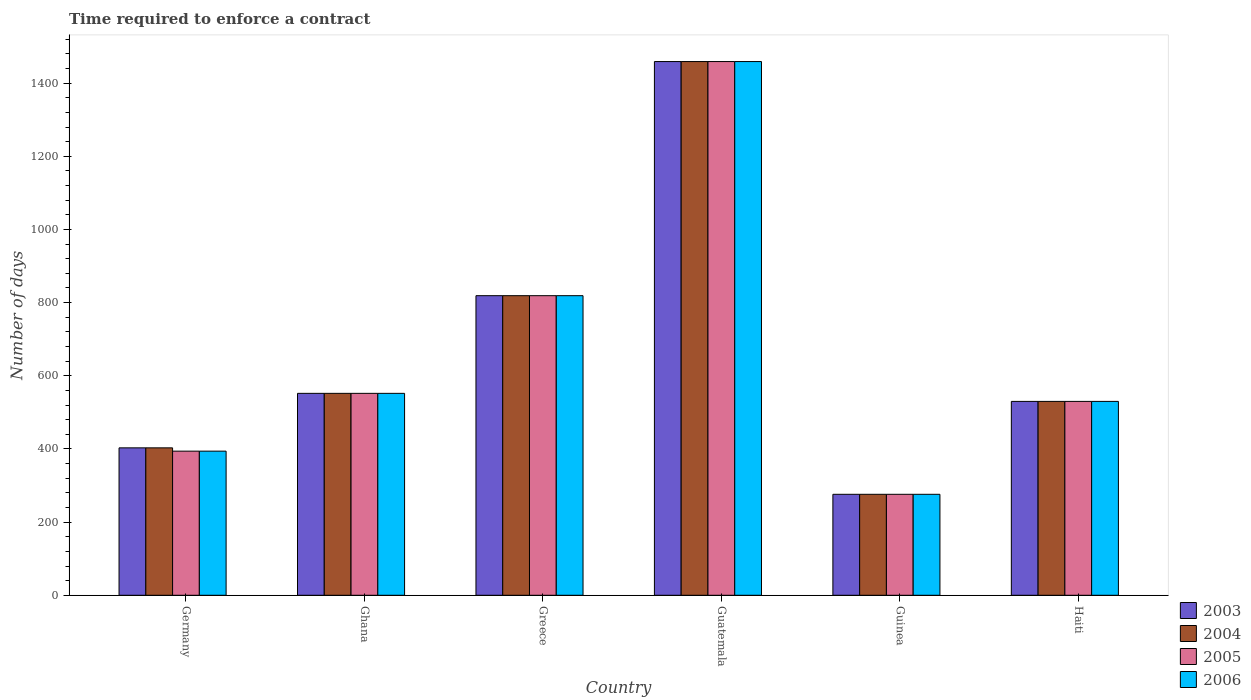Are the number of bars per tick equal to the number of legend labels?
Offer a terse response. Yes. Are the number of bars on each tick of the X-axis equal?
Provide a short and direct response. Yes. How many bars are there on the 1st tick from the right?
Ensure brevity in your answer.  4. What is the number of days required to enforce a contract in 2004 in Guinea?
Make the answer very short. 276. Across all countries, what is the maximum number of days required to enforce a contract in 2006?
Offer a very short reply. 1459. Across all countries, what is the minimum number of days required to enforce a contract in 2006?
Keep it short and to the point. 276. In which country was the number of days required to enforce a contract in 2006 maximum?
Provide a short and direct response. Guatemala. In which country was the number of days required to enforce a contract in 2004 minimum?
Your response must be concise. Guinea. What is the total number of days required to enforce a contract in 2006 in the graph?
Your response must be concise. 4030. What is the difference between the number of days required to enforce a contract in 2004 in Guinea and that in Haiti?
Your answer should be very brief. -254. What is the difference between the number of days required to enforce a contract in 2005 in Germany and the number of days required to enforce a contract in 2006 in Ghana?
Provide a succinct answer. -158. What is the average number of days required to enforce a contract in 2003 per country?
Offer a very short reply. 673.17. What is the difference between the number of days required to enforce a contract of/in 2003 and number of days required to enforce a contract of/in 2005 in Ghana?
Your response must be concise. 0. What is the ratio of the number of days required to enforce a contract in 2005 in Ghana to that in Guinea?
Make the answer very short. 2. Is the number of days required to enforce a contract in 2004 in Guatemala less than that in Guinea?
Provide a short and direct response. No. What is the difference between the highest and the second highest number of days required to enforce a contract in 2006?
Your answer should be very brief. -267. What is the difference between the highest and the lowest number of days required to enforce a contract in 2004?
Make the answer very short. 1183. In how many countries, is the number of days required to enforce a contract in 2004 greater than the average number of days required to enforce a contract in 2004 taken over all countries?
Offer a very short reply. 2. What does the 3rd bar from the right in Germany represents?
Your answer should be compact. 2004. How many bars are there?
Offer a terse response. 24. How many countries are there in the graph?
Give a very brief answer. 6. Are the values on the major ticks of Y-axis written in scientific E-notation?
Ensure brevity in your answer.  No. Does the graph contain any zero values?
Your answer should be compact. No. Where does the legend appear in the graph?
Your answer should be compact. Bottom right. What is the title of the graph?
Give a very brief answer. Time required to enforce a contract. What is the label or title of the Y-axis?
Your response must be concise. Number of days. What is the Number of days in 2003 in Germany?
Give a very brief answer. 403. What is the Number of days in 2004 in Germany?
Provide a succinct answer. 403. What is the Number of days in 2005 in Germany?
Ensure brevity in your answer.  394. What is the Number of days of 2006 in Germany?
Keep it short and to the point. 394. What is the Number of days in 2003 in Ghana?
Your answer should be compact. 552. What is the Number of days in 2004 in Ghana?
Make the answer very short. 552. What is the Number of days in 2005 in Ghana?
Your answer should be very brief. 552. What is the Number of days of 2006 in Ghana?
Give a very brief answer. 552. What is the Number of days of 2003 in Greece?
Your response must be concise. 819. What is the Number of days in 2004 in Greece?
Offer a terse response. 819. What is the Number of days of 2005 in Greece?
Offer a very short reply. 819. What is the Number of days of 2006 in Greece?
Provide a short and direct response. 819. What is the Number of days of 2003 in Guatemala?
Your response must be concise. 1459. What is the Number of days in 2004 in Guatemala?
Offer a terse response. 1459. What is the Number of days in 2005 in Guatemala?
Provide a succinct answer. 1459. What is the Number of days of 2006 in Guatemala?
Make the answer very short. 1459. What is the Number of days in 2003 in Guinea?
Offer a very short reply. 276. What is the Number of days in 2004 in Guinea?
Keep it short and to the point. 276. What is the Number of days in 2005 in Guinea?
Offer a very short reply. 276. What is the Number of days in 2006 in Guinea?
Give a very brief answer. 276. What is the Number of days of 2003 in Haiti?
Keep it short and to the point. 530. What is the Number of days in 2004 in Haiti?
Provide a succinct answer. 530. What is the Number of days in 2005 in Haiti?
Provide a short and direct response. 530. What is the Number of days in 2006 in Haiti?
Your response must be concise. 530. Across all countries, what is the maximum Number of days of 2003?
Offer a very short reply. 1459. Across all countries, what is the maximum Number of days in 2004?
Offer a terse response. 1459. Across all countries, what is the maximum Number of days of 2005?
Make the answer very short. 1459. Across all countries, what is the maximum Number of days in 2006?
Make the answer very short. 1459. Across all countries, what is the minimum Number of days in 2003?
Keep it short and to the point. 276. Across all countries, what is the minimum Number of days of 2004?
Your response must be concise. 276. Across all countries, what is the minimum Number of days of 2005?
Keep it short and to the point. 276. Across all countries, what is the minimum Number of days in 2006?
Your answer should be very brief. 276. What is the total Number of days of 2003 in the graph?
Make the answer very short. 4039. What is the total Number of days of 2004 in the graph?
Provide a short and direct response. 4039. What is the total Number of days of 2005 in the graph?
Give a very brief answer. 4030. What is the total Number of days in 2006 in the graph?
Offer a very short reply. 4030. What is the difference between the Number of days in 2003 in Germany and that in Ghana?
Offer a very short reply. -149. What is the difference between the Number of days in 2004 in Germany and that in Ghana?
Offer a very short reply. -149. What is the difference between the Number of days in 2005 in Germany and that in Ghana?
Provide a short and direct response. -158. What is the difference between the Number of days in 2006 in Germany and that in Ghana?
Your answer should be very brief. -158. What is the difference between the Number of days of 2003 in Germany and that in Greece?
Provide a short and direct response. -416. What is the difference between the Number of days of 2004 in Germany and that in Greece?
Your answer should be compact. -416. What is the difference between the Number of days of 2005 in Germany and that in Greece?
Your answer should be very brief. -425. What is the difference between the Number of days in 2006 in Germany and that in Greece?
Ensure brevity in your answer.  -425. What is the difference between the Number of days in 2003 in Germany and that in Guatemala?
Ensure brevity in your answer.  -1056. What is the difference between the Number of days of 2004 in Germany and that in Guatemala?
Your answer should be very brief. -1056. What is the difference between the Number of days of 2005 in Germany and that in Guatemala?
Your answer should be compact. -1065. What is the difference between the Number of days in 2006 in Germany and that in Guatemala?
Offer a very short reply. -1065. What is the difference between the Number of days in 2003 in Germany and that in Guinea?
Your response must be concise. 127. What is the difference between the Number of days in 2004 in Germany and that in Guinea?
Offer a very short reply. 127. What is the difference between the Number of days of 2005 in Germany and that in Guinea?
Keep it short and to the point. 118. What is the difference between the Number of days in 2006 in Germany and that in Guinea?
Keep it short and to the point. 118. What is the difference between the Number of days in 2003 in Germany and that in Haiti?
Your answer should be very brief. -127. What is the difference between the Number of days in 2004 in Germany and that in Haiti?
Keep it short and to the point. -127. What is the difference between the Number of days in 2005 in Germany and that in Haiti?
Your answer should be very brief. -136. What is the difference between the Number of days in 2006 in Germany and that in Haiti?
Offer a very short reply. -136. What is the difference between the Number of days in 2003 in Ghana and that in Greece?
Make the answer very short. -267. What is the difference between the Number of days of 2004 in Ghana and that in Greece?
Your answer should be very brief. -267. What is the difference between the Number of days of 2005 in Ghana and that in Greece?
Your answer should be compact. -267. What is the difference between the Number of days in 2006 in Ghana and that in Greece?
Provide a short and direct response. -267. What is the difference between the Number of days of 2003 in Ghana and that in Guatemala?
Keep it short and to the point. -907. What is the difference between the Number of days of 2004 in Ghana and that in Guatemala?
Your answer should be compact. -907. What is the difference between the Number of days of 2005 in Ghana and that in Guatemala?
Make the answer very short. -907. What is the difference between the Number of days of 2006 in Ghana and that in Guatemala?
Ensure brevity in your answer.  -907. What is the difference between the Number of days of 2003 in Ghana and that in Guinea?
Give a very brief answer. 276. What is the difference between the Number of days in 2004 in Ghana and that in Guinea?
Make the answer very short. 276. What is the difference between the Number of days in 2005 in Ghana and that in Guinea?
Provide a succinct answer. 276. What is the difference between the Number of days of 2006 in Ghana and that in Guinea?
Ensure brevity in your answer.  276. What is the difference between the Number of days in 2004 in Ghana and that in Haiti?
Offer a very short reply. 22. What is the difference between the Number of days in 2005 in Ghana and that in Haiti?
Provide a succinct answer. 22. What is the difference between the Number of days of 2006 in Ghana and that in Haiti?
Provide a succinct answer. 22. What is the difference between the Number of days of 2003 in Greece and that in Guatemala?
Ensure brevity in your answer.  -640. What is the difference between the Number of days in 2004 in Greece and that in Guatemala?
Your answer should be very brief. -640. What is the difference between the Number of days in 2005 in Greece and that in Guatemala?
Your response must be concise. -640. What is the difference between the Number of days of 2006 in Greece and that in Guatemala?
Offer a terse response. -640. What is the difference between the Number of days in 2003 in Greece and that in Guinea?
Offer a terse response. 543. What is the difference between the Number of days in 2004 in Greece and that in Guinea?
Your response must be concise. 543. What is the difference between the Number of days in 2005 in Greece and that in Guinea?
Your response must be concise. 543. What is the difference between the Number of days of 2006 in Greece and that in Guinea?
Provide a succinct answer. 543. What is the difference between the Number of days in 2003 in Greece and that in Haiti?
Ensure brevity in your answer.  289. What is the difference between the Number of days of 2004 in Greece and that in Haiti?
Offer a terse response. 289. What is the difference between the Number of days in 2005 in Greece and that in Haiti?
Keep it short and to the point. 289. What is the difference between the Number of days of 2006 in Greece and that in Haiti?
Ensure brevity in your answer.  289. What is the difference between the Number of days of 2003 in Guatemala and that in Guinea?
Make the answer very short. 1183. What is the difference between the Number of days of 2004 in Guatemala and that in Guinea?
Give a very brief answer. 1183. What is the difference between the Number of days in 2005 in Guatemala and that in Guinea?
Offer a very short reply. 1183. What is the difference between the Number of days in 2006 in Guatemala and that in Guinea?
Keep it short and to the point. 1183. What is the difference between the Number of days in 2003 in Guatemala and that in Haiti?
Your response must be concise. 929. What is the difference between the Number of days in 2004 in Guatemala and that in Haiti?
Your answer should be very brief. 929. What is the difference between the Number of days of 2005 in Guatemala and that in Haiti?
Ensure brevity in your answer.  929. What is the difference between the Number of days of 2006 in Guatemala and that in Haiti?
Your answer should be very brief. 929. What is the difference between the Number of days of 2003 in Guinea and that in Haiti?
Give a very brief answer. -254. What is the difference between the Number of days of 2004 in Guinea and that in Haiti?
Provide a succinct answer. -254. What is the difference between the Number of days in 2005 in Guinea and that in Haiti?
Your answer should be very brief. -254. What is the difference between the Number of days of 2006 in Guinea and that in Haiti?
Provide a short and direct response. -254. What is the difference between the Number of days in 2003 in Germany and the Number of days in 2004 in Ghana?
Your response must be concise. -149. What is the difference between the Number of days of 2003 in Germany and the Number of days of 2005 in Ghana?
Offer a very short reply. -149. What is the difference between the Number of days in 2003 in Germany and the Number of days in 2006 in Ghana?
Provide a short and direct response. -149. What is the difference between the Number of days of 2004 in Germany and the Number of days of 2005 in Ghana?
Your answer should be very brief. -149. What is the difference between the Number of days of 2004 in Germany and the Number of days of 2006 in Ghana?
Provide a short and direct response. -149. What is the difference between the Number of days of 2005 in Germany and the Number of days of 2006 in Ghana?
Provide a succinct answer. -158. What is the difference between the Number of days of 2003 in Germany and the Number of days of 2004 in Greece?
Offer a very short reply. -416. What is the difference between the Number of days of 2003 in Germany and the Number of days of 2005 in Greece?
Your answer should be compact. -416. What is the difference between the Number of days in 2003 in Germany and the Number of days in 2006 in Greece?
Your response must be concise. -416. What is the difference between the Number of days of 2004 in Germany and the Number of days of 2005 in Greece?
Make the answer very short. -416. What is the difference between the Number of days of 2004 in Germany and the Number of days of 2006 in Greece?
Keep it short and to the point. -416. What is the difference between the Number of days in 2005 in Germany and the Number of days in 2006 in Greece?
Provide a succinct answer. -425. What is the difference between the Number of days in 2003 in Germany and the Number of days in 2004 in Guatemala?
Offer a very short reply. -1056. What is the difference between the Number of days of 2003 in Germany and the Number of days of 2005 in Guatemala?
Keep it short and to the point. -1056. What is the difference between the Number of days in 2003 in Germany and the Number of days in 2006 in Guatemala?
Provide a succinct answer. -1056. What is the difference between the Number of days of 2004 in Germany and the Number of days of 2005 in Guatemala?
Make the answer very short. -1056. What is the difference between the Number of days of 2004 in Germany and the Number of days of 2006 in Guatemala?
Ensure brevity in your answer.  -1056. What is the difference between the Number of days in 2005 in Germany and the Number of days in 2006 in Guatemala?
Provide a succinct answer. -1065. What is the difference between the Number of days in 2003 in Germany and the Number of days in 2004 in Guinea?
Make the answer very short. 127. What is the difference between the Number of days in 2003 in Germany and the Number of days in 2005 in Guinea?
Your answer should be compact. 127. What is the difference between the Number of days of 2003 in Germany and the Number of days of 2006 in Guinea?
Provide a succinct answer. 127. What is the difference between the Number of days of 2004 in Germany and the Number of days of 2005 in Guinea?
Provide a succinct answer. 127. What is the difference between the Number of days in 2004 in Germany and the Number of days in 2006 in Guinea?
Offer a terse response. 127. What is the difference between the Number of days in 2005 in Germany and the Number of days in 2006 in Guinea?
Your answer should be compact. 118. What is the difference between the Number of days in 2003 in Germany and the Number of days in 2004 in Haiti?
Provide a short and direct response. -127. What is the difference between the Number of days of 2003 in Germany and the Number of days of 2005 in Haiti?
Your response must be concise. -127. What is the difference between the Number of days in 2003 in Germany and the Number of days in 2006 in Haiti?
Your answer should be very brief. -127. What is the difference between the Number of days of 2004 in Germany and the Number of days of 2005 in Haiti?
Your answer should be compact. -127. What is the difference between the Number of days in 2004 in Germany and the Number of days in 2006 in Haiti?
Ensure brevity in your answer.  -127. What is the difference between the Number of days of 2005 in Germany and the Number of days of 2006 in Haiti?
Your answer should be compact. -136. What is the difference between the Number of days in 2003 in Ghana and the Number of days in 2004 in Greece?
Offer a very short reply. -267. What is the difference between the Number of days of 2003 in Ghana and the Number of days of 2005 in Greece?
Ensure brevity in your answer.  -267. What is the difference between the Number of days in 2003 in Ghana and the Number of days in 2006 in Greece?
Offer a terse response. -267. What is the difference between the Number of days of 2004 in Ghana and the Number of days of 2005 in Greece?
Provide a succinct answer. -267. What is the difference between the Number of days in 2004 in Ghana and the Number of days in 2006 in Greece?
Ensure brevity in your answer.  -267. What is the difference between the Number of days in 2005 in Ghana and the Number of days in 2006 in Greece?
Your answer should be very brief. -267. What is the difference between the Number of days of 2003 in Ghana and the Number of days of 2004 in Guatemala?
Offer a terse response. -907. What is the difference between the Number of days of 2003 in Ghana and the Number of days of 2005 in Guatemala?
Ensure brevity in your answer.  -907. What is the difference between the Number of days of 2003 in Ghana and the Number of days of 2006 in Guatemala?
Offer a very short reply. -907. What is the difference between the Number of days in 2004 in Ghana and the Number of days in 2005 in Guatemala?
Your answer should be very brief. -907. What is the difference between the Number of days of 2004 in Ghana and the Number of days of 2006 in Guatemala?
Make the answer very short. -907. What is the difference between the Number of days of 2005 in Ghana and the Number of days of 2006 in Guatemala?
Keep it short and to the point. -907. What is the difference between the Number of days in 2003 in Ghana and the Number of days in 2004 in Guinea?
Make the answer very short. 276. What is the difference between the Number of days in 2003 in Ghana and the Number of days in 2005 in Guinea?
Provide a succinct answer. 276. What is the difference between the Number of days in 2003 in Ghana and the Number of days in 2006 in Guinea?
Offer a very short reply. 276. What is the difference between the Number of days of 2004 in Ghana and the Number of days of 2005 in Guinea?
Keep it short and to the point. 276. What is the difference between the Number of days in 2004 in Ghana and the Number of days in 2006 in Guinea?
Give a very brief answer. 276. What is the difference between the Number of days of 2005 in Ghana and the Number of days of 2006 in Guinea?
Ensure brevity in your answer.  276. What is the difference between the Number of days in 2003 in Ghana and the Number of days in 2004 in Haiti?
Offer a terse response. 22. What is the difference between the Number of days in 2004 in Ghana and the Number of days in 2006 in Haiti?
Ensure brevity in your answer.  22. What is the difference between the Number of days of 2003 in Greece and the Number of days of 2004 in Guatemala?
Give a very brief answer. -640. What is the difference between the Number of days of 2003 in Greece and the Number of days of 2005 in Guatemala?
Offer a terse response. -640. What is the difference between the Number of days in 2003 in Greece and the Number of days in 2006 in Guatemala?
Your answer should be compact. -640. What is the difference between the Number of days in 2004 in Greece and the Number of days in 2005 in Guatemala?
Keep it short and to the point. -640. What is the difference between the Number of days of 2004 in Greece and the Number of days of 2006 in Guatemala?
Your response must be concise. -640. What is the difference between the Number of days in 2005 in Greece and the Number of days in 2006 in Guatemala?
Keep it short and to the point. -640. What is the difference between the Number of days in 2003 in Greece and the Number of days in 2004 in Guinea?
Provide a succinct answer. 543. What is the difference between the Number of days in 2003 in Greece and the Number of days in 2005 in Guinea?
Your answer should be very brief. 543. What is the difference between the Number of days in 2003 in Greece and the Number of days in 2006 in Guinea?
Offer a very short reply. 543. What is the difference between the Number of days in 2004 in Greece and the Number of days in 2005 in Guinea?
Your answer should be very brief. 543. What is the difference between the Number of days in 2004 in Greece and the Number of days in 2006 in Guinea?
Give a very brief answer. 543. What is the difference between the Number of days in 2005 in Greece and the Number of days in 2006 in Guinea?
Provide a succinct answer. 543. What is the difference between the Number of days in 2003 in Greece and the Number of days in 2004 in Haiti?
Your answer should be very brief. 289. What is the difference between the Number of days in 2003 in Greece and the Number of days in 2005 in Haiti?
Provide a short and direct response. 289. What is the difference between the Number of days of 2003 in Greece and the Number of days of 2006 in Haiti?
Your response must be concise. 289. What is the difference between the Number of days in 2004 in Greece and the Number of days in 2005 in Haiti?
Ensure brevity in your answer.  289. What is the difference between the Number of days of 2004 in Greece and the Number of days of 2006 in Haiti?
Make the answer very short. 289. What is the difference between the Number of days in 2005 in Greece and the Number of days in 2006 in Haiti?
Ensure brevity in your answer.  289. What is the difference between the Number of days of 2003 in Guatemala and the Number of days of 2004 in Guinea?
Offer a terse response. 1183. What is the difference between the Number of days in 2003 in Guatemala and the Number of days in 2005 in Guinea?
Provide a short and direct response. 1183. What is the difference between the Number of days in 2003 in Guatemala and the Number of days in 2006 in Guinea?
Make the answer very short. 1183. What is the difference between the Number of days of 2004 in Guatemala and the Number of days of 2005 in Guinea?
Keep it short and to the point. 1183. What is the difference between the Number of days in 2004 in Guatemala and the Number of days in 2006 in Guinea?
Your answer should be compact. 1183. What is the difference between the Number of days in 2005 in Guatemala and the Number of days in 2006 in Guinea?
Ensure brevity in your answer.  1183. What is the difference between the Number of days in 2003 in Guatemala and the Number of days in 2004 in Haiti?
Offer a terse response. 929. What is the difference between the Number of days in 2003 in Guatemala and the Number of days in 2005 in Haiti?
Ensure brevity in your answer.  929. What is the difference between the Number of days of 2003 in Guatemala and the Number of days of 2006 in Haiti?
Your answer should be compact. 929. What is the difference between the Number of days of 2004 in Guatemala and the Number of days of 2005 in Haiti?
Offer a terse response. 929. What is the difference between the Number of days of 2004 in Guatemala and the Number of days of 2006 in Haiti?
Your response must be concise. 929. What is the difference between the Number of days in 2005 in Guatemala and the Number of days in 2006 in Haiti?
Your answer should be very brief. 929. What is the difference between the Number of days of 2003 in Guinea and the Number of days of 2004 in Haiti?
Make the answer very short. -254. What is the difference between the Number of days of 2003 in Guinea and the Number of days of 2005 in Haiti?
Ensure brevity in your answer.  -254. What is the difference between the Number of days of 2003 in Guinea and the Number of days of 2006 in Haiti?
Give a very brief answer. -254. What is the difference between the Number of days of 2004 in Guinea and the Number of days of 2005 in Haiti?
Give a very brief answer. -254. What is the difference between the Number of days in 2004 in Guinea and the Number of days in 2006 in Haiti?
Ensure brevity in your answer.  -254. What is the difference between the Number of days in 2005 in Guinea and the Number of days in 2006 in Haiti?
Give a very brief answer. -254. What is the average Number of days of 2003 per country?
Provide a succinct answer. 673.17. What is the average Number of days of 2004 per country?
Give a very brief answer. 673.17. What is the average Number of days in 2005 per country?
Provide a short and direct response. 671.67. What is the average Number of days in 2006 per country?
Your response must be concise. 671.67. What is the difference between the Number of days of 2003 and Number of days of 2004 in Germany?
Your answer should be compact. 0. What is the difference between the Number of days in 2004 and Number of days in 2006 in Germany?
Your response must be concise. 9. What is the difference between the Number of days in 2003 and Number of days in 2005 in Ghana?
Offer a very short reply. 0. What is the difference between the Number of days of 2003 and Number of days of 2006 in Ghana?
Provide a short and direct response. 0. What is the difference between the Number of days of 2004 and Number of days of 2005 in Ghana?
Your response must be concise. 0. What is the difference between the Number of days of 2004 and Number of days of 2006 in Ghana?
Offer a terse response. 0. What is the difference between the Number of days of 2003 and Number of days of 2004 in Greece?
Make the answer very short. 0. What is the difference between the Number of days in 2003 and Number of days in 2005 in Greece?
Your response must be concise. 0. What is the difference between the Number of days of 2003 and Number of days of 2006 in Greece?
Provide a succinct answer. 0. What is the difference between the Number of days in 2004 and Number of days in 2005 in Greece?
Offer a terse response. 0. What is the difference between the Number of days of 2004 and Number of days of 2006 in Greece?
Give a very brief answer. 0. What is the difference between the Number of days of 2005 and Number of days of 2006 in Greece?
Keep it short and to the point. 0. What is the difference between the Number of days of 2003 and Number of days of 2004 in Guatemala?
Ensure brevity in your answer.  0. What is the difference between the Number of days in 2003 and Number of days in 2006 in Guatemala?
Offer a very short reply. 0. What is the difference between the Number of days of 2004 and Number of days of 2005 in Guatemala?
Make the answer very short. 0. What is the difference between the Number of days of 2005 and Number of days of 2006 in Guatemala?
Provide a succinct answer. 0. What is the difference between the Number of days in 2003 and Number of days in 2005 in Guinea?
Provide a succinct answer. 0. What is the difference between the Number of days of 2004 and Number of days of 2006 in Guinea?
Provide a short and direct response. 0. What is the difference between the Number of days in 2005 and Number of days in 2006 in Guinea?
Provide a short and direct response. 0. What is the difference between the Number of days of 2003 and Number of days of 2006 in Haiti?
Provide a succinct answer. 0. What is the difference between the Number of days in 2005 and Number of days in 2006 in Haiti?
Your response must be concise. 0. What is the ratio of the Number of days of 2003 in Germany to that in Ghana?
Provide a succinct answer. 0.73. What is the ratio of the Number of days of 2004 in Germany to that in Ghana?
Keep it short and to the point. 0.73. What is the ratio of the Number of days of 2005 in Germany to that in Ghana?
Ensure brevity in your answer.  0.71. What is the ratio of the Number of days of 2006 in Germany to that in Ghana?
Provide a short and direct response. 0.71. What is the ratio of the Number of days in 2003 in Germany to that in Greece?
Provide a succinct answer. 0.49. What is the ratio of the Number of days of 2004 in Germany to that in Greece?
Offer a very short reply. 0.49. What is the ratio of the Number of days in 2005 in Germany to that in Greece?
Give a very brief answer. 0.48. What is the ratio of the Number of days of 2006 in Germany to that in Greece?
Make the answer very short. 0.48. What is the ratio of the Number of days in 2003 in Germany to that in Guatemala?
Offer a terse response. 0.28. What is the ratio of the Number of days in 2004 in Germany to that in Guatemala?
Offer a very short reply. 0.28. What is the ratio of the Number of days of 2005 in Germany to that in Guatemala?
Your answer should be very brief. 0.27. What is the ratio of the Number of days of 2006 in Germany to that in Guatemala?
Offer a very short reply. 0.27. What is the ratio of the Number of days of 2003 in Germany to that in Guinea?
Your response must be concise. 1.46. What is the ratio of the Number of days in 2004 in Germany to that in Guinea?
Provide a short and direct response. 1.46. What is the ratio of the Number of days in 2005 in Germany to that in Guinea?
Your answer should be very brief. 1.43. What is the ratio of the Number of days of 2006 in Germany to that in Guinea?
Give a very brief answer. 1.43. What is the ratio of the Number of days in 2003 in Germany to that in Haiti?
Give a very brief answer. 0.76. What is the ratio of the Number of days of 2004 in Germany to that in Haiti?
Your answer should be very brief. 0.76. What is the ratio of the Number of days in 2005 in Germany to that in Haiti?
Give a very brief answer. 0.74. What is the ratio of the Number of days in 2006 in Germany to that in Haiti?
Provide a short and direct response. 0.74. What is the ratio of the Number of days in 2003 in Ghana to that in Greece?
Make the answer very short. 0.67. What is the ratio of the Number of days of 2004 in Ghana to that in Greece?
Make the answer very short. 0.67. What is the ratio of the Number of days in 2005 in Ghana to that in Greece?
Your response must be concise. 0.67. What is the ratio of the Number of days in 2006 in Ghana to that in Greece?
Provide a short and direct response. 0.67. What is the ratio of the Number of days of 2003 in Ghana to that in Guatemala?
Offer a very short reply. 0.38. What is the ratio of the Number of days of 2004 in Ghana to that in Guatemala?
Make the answer very short. 0.38. What is the ratio of the Number of days of 2005 in Ghana to that in Guatemala?
Provide a short and direct response. 0.38. What is the ratio of the Number of days of 2006 in Ghana to that in Guatemala?
Offer a terse response. 0.38. What is the ratio of the Number of days in 2003 in Ghana to that in Guinea?
Offer a very short reply. 2. What is the ratio of the Number of days of 2004 in Ghana to that in Guinea?
Provide a succinct answer. 2. What is the ratio of the Number of days of 2005 in Ghana to that in Guinea?
Offer a very short reply. 2. What is the ratio of the Number of days of 2003 in Ghana to that in Haiti?
Your answer should be very brief. 1.04. What is the ratio of the Number of days of 2004 in Ghana to that in Haiti?
Make the answer very short. 1.04. What is the ratio of the Number of days in 2005 in Ghana to that in Haiti?
Your answer should be very brief. 1.04. What is the ratio of the Number of days in 2006 in Ghana to that in Haiti?
Offer a terse response. 1.04. What is the ratio of the Number of days in 2003 in Greece to that in Guatemala?
Make the answer very short. 0.56. What is the ratio of the Number of days of 2004 in Greece to that in Guatemala?
Provide a short and direct response. 0.56. What is the ratio of the Number of days of 2005 in Greece to that in Guatemala?
Offer a very short reply. 0.56. What is the ratio of the Number of days of 2006 in Greece to that in Guatemala?
Make the answer very short. 0.56. What is the ratio of the Number of days of 2003 in Greece to that in Guinea?
Ensure brevity in your answer.  2.97. What is the ratio of the Number of days of 2004 in Greece to that in Guinea?
Your response must be concise. 2.97. What is the ratio of the Number of days of 2005 in Greece to that in Guinea?
Offer a terse response. 2.97. What is the ratio of the Number of days of 2006 in Greece to that in Guinea?
Keep it short and to the point. 2.97. What is the ratio of the Number of days in 2003 in Greece to that in Haiti?
Give a very brief answer. 1.55. What is the ratio of the Number of days in 2004 in Greece to that in Haiti?
Make the answer very short. 1.55. What is the ratio of the Number of days of 2005 in Greece to that in Haiti?
Provide a short and direct response. 1.55. What is the ratio of the Number of days in 2006 in Greece to that in Haiti?
Give a very brief answer. 1.55. What is the ratio of the Number of days in 2003 in Guatemala to that in Guinea?
Provide a short and direct response. 5.29. What is the ratio of the Number of days in 2004 in Guatemala to that in Guinea?
Keep it short and to the point. 5.29. What is the ratio of the Number of days of 2005 in Guatemala to that in Guinea?
Ensure brevity in your answer.  5.29. What is the ratio of the Number of days of 2006 in Guatemala to that in Guinea?
Give a very brief answer. 5.29. What is the ratio of the Number of days of 2003 in Guatemala to that in Haiti?
Provide a short and direct response. 2.75. What is the ratio of the Number of days of 2004 in Guatemala to that in Haiti?
Keep it short and to the point. 2.75. What is the ratio of the Number of days in 2005 in Guatemala to that in Haiti?
Your answer should be compact. 2.75. What is the ratio of the Number of days of 2006 in Guatemala to that in Haiti?
Give a very brief answer. 2.75. What is the ratio of the Number of days in 2003 in Guinea to that in Haiti?
Provide a succinct answer. 0.52. What is the ratio of the Number of days in 2004 in Guinea to that in Haiti?
Ensure brevity in your answer.  0.52. What is the ratio of the Number of days of 2005 in Guinea to that in Haiti?
Offer a terse response. 0.52. What is the ratio of the Number of days in 2006 in Guinea to that in Haiti?
Make the answer very short. 0.52. What is the difference between the highest and the second highest Number of days of 2003?
Offer a terse response. 640. What is the difference between the highest and the second highest Number of days in 2004?
Keep it short and to the point. 640. What is the difference between the highest and the second highest Number of days in 2005?
Provide a short and direct response. 640. What is the difference between the highest and the second highest Number of days in 2006?
Your answer should be very brief. 640. What is the difference between the highest and the lowest Number of days in 2003?
Offer a very short reply. 1183. What is the difference between the highest and the lowest Number of days of 2004?
Your response must be concise. 1183. What is the difference between the highest and the lowest Number of days in 2005?
Ensure brevity in your answer.  1183. What is the difference between the highest and the lowest Number of days of 2006?
Your answer should be compact. 1183. 